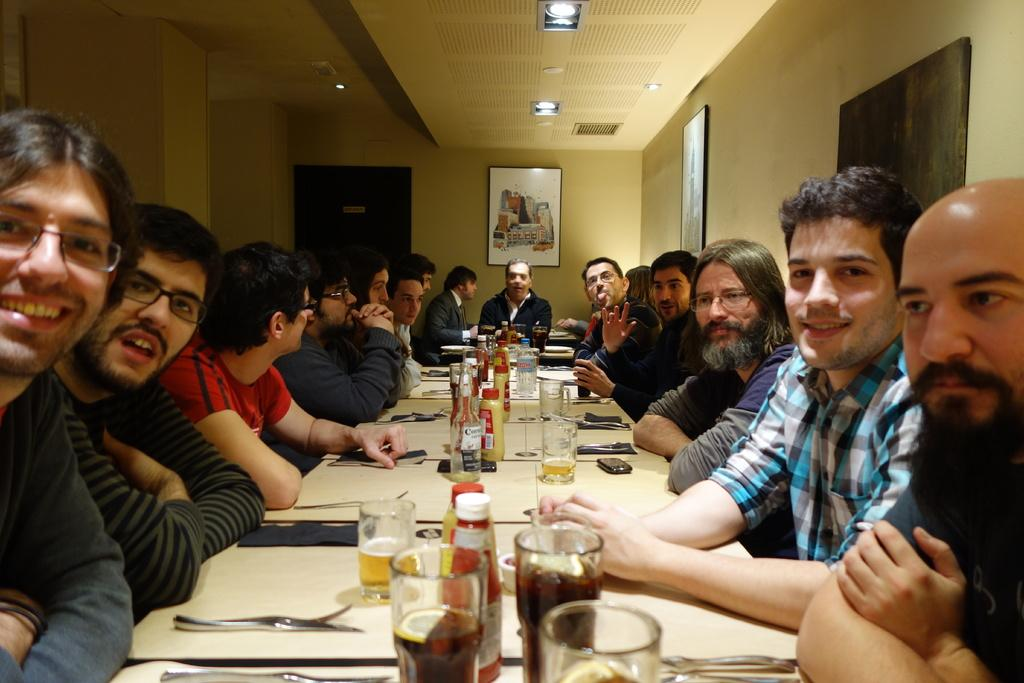What type of structure can be seen in the image? There is a wall in the image. What is hanging on the wall? There is a photo frame in the image. What are the people in the image doing? There are people sitting on chairs in the image. What is on the table in the image? There are glasses, bottles, mobile phones, forks, and spoons on the table. How many children are playing in the alley in the image? There is no alley or children present in the image. What type of shake is being prepared on the table in the image? There is no shake being prepared on the table in the image; there are only glasses, bottles, mobile phones, forks, and spoons. 